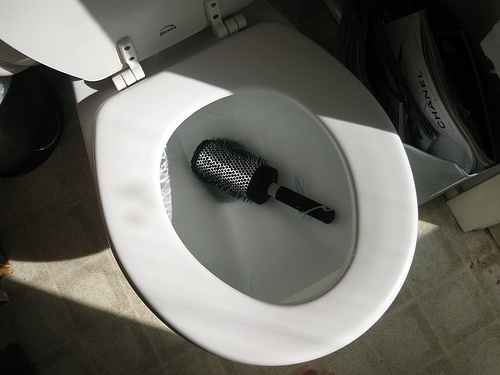Describe the objects in this image and their specific colors. I can see a toilet in lightgray, gray, black, and darkgray tones in this image. 